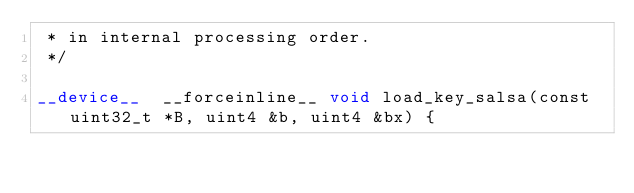Convert code to text. <code><loc_0><loc_0><loc_500><loc_500><_Cuda_> * in internal processing order.
 */

__device__  __forceinline__ void load_key_salsa(const uint32_t *B, uint4 &b, uint4 &bx) {</code> 